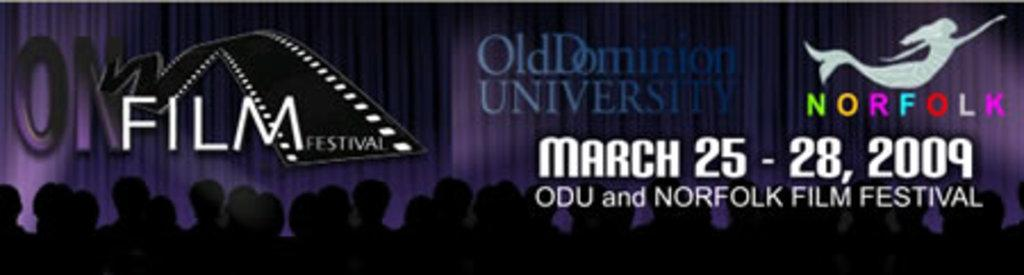What is present in the image related to an event? There is a poster in the image that contains information about an event. What specific details about the event can be found on the poster? The poster contains an event name, a date, and a logo. How many girls are depicted on the poster? There are no girls depicted on the poster; it only contains information about an event. 